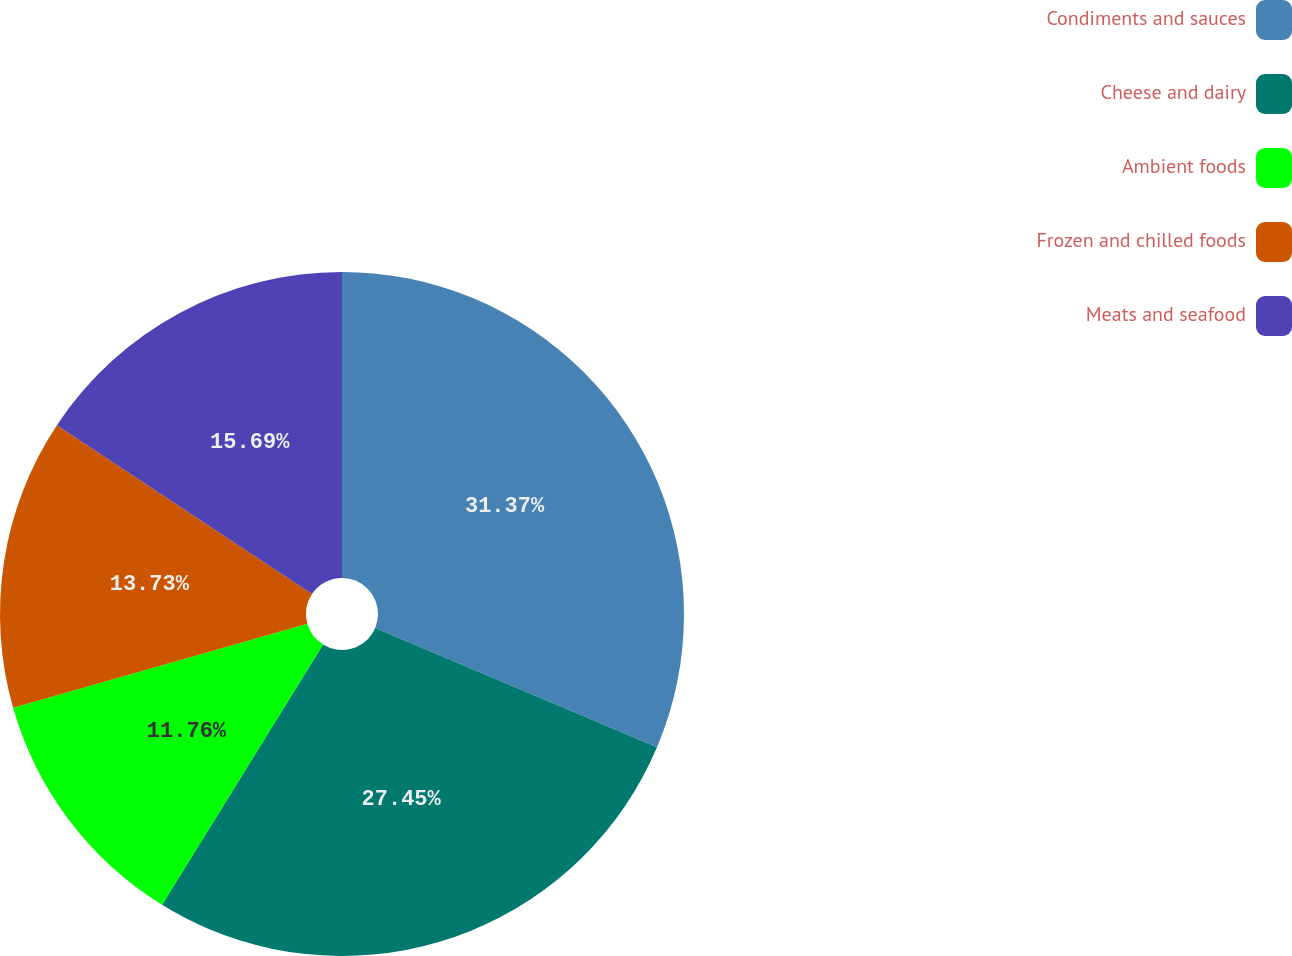Convert chart. <chart><loc_0><loc_0><loc_500><loc_500><pie_chart><fcel>Condiments and sauces<fcel>Cheese and dairy<fcel>Ambient foods<fcel>Frozen and chilled foods<fcel>Meats and seafood<nl><fcel>31.37%<fcel>27.45%<fcel>11.76%<fcel>13.73%<fcel>15.69%<nl></chart> 